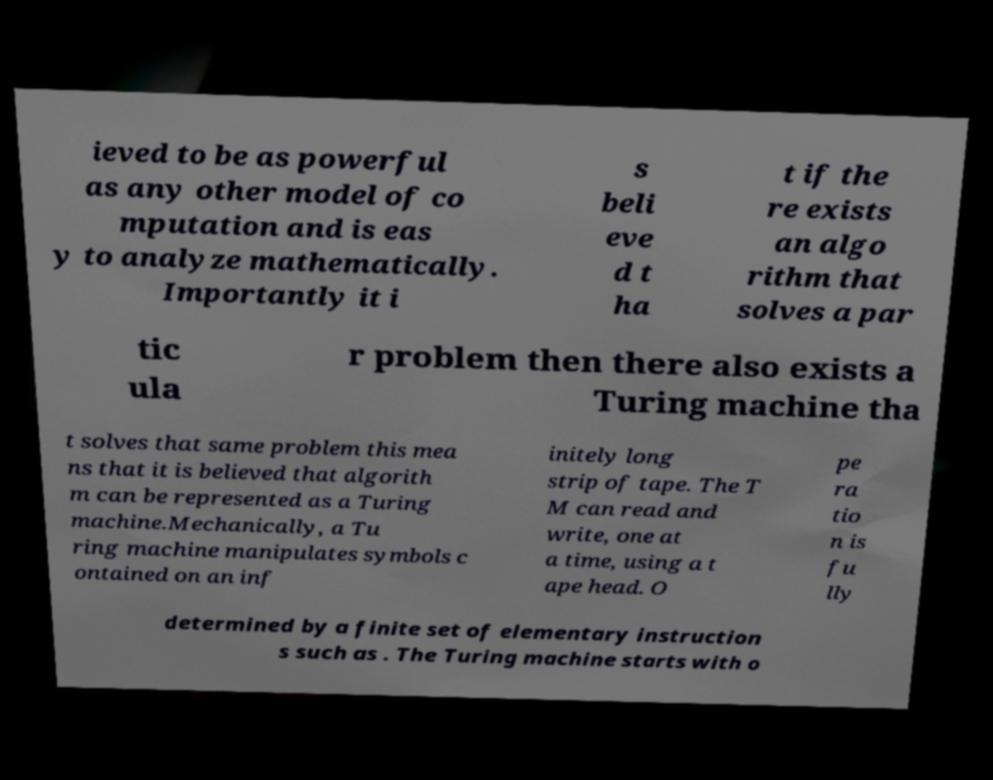I need the written content from this picture converted into text. Can you do that? ieved to be as powerful as any other model of co mputation and is eas y to analyze mathematically. Importantly it i s beli eve d t ha t if the re exists an algo rithm that solves a par tic ula r problem then there also exists a Turing machine tha t solves that same problem this mea ns that it is believed that algorith m can be represented as a Turing machine.Mechanically, a Tu ring machine manipulates symbols c ontained on an inf initely long strip of tape. The T M can read and write, one at a time, using a t ape head. O pe ra tio n is fu lly determined by a finite set of elementary instruction s such as . The Turing machine starts with o 